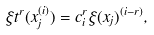Convert formula to latex. <formula><loc_0><loc_0><loc_500><loc_500>\xi t ^ { r } ( x _ { j } ^ { ( i ) } ) = c ^ { r } _ { i } \xi ( x _ { j } ) ^ { ( i - r ) } ,</formula> 